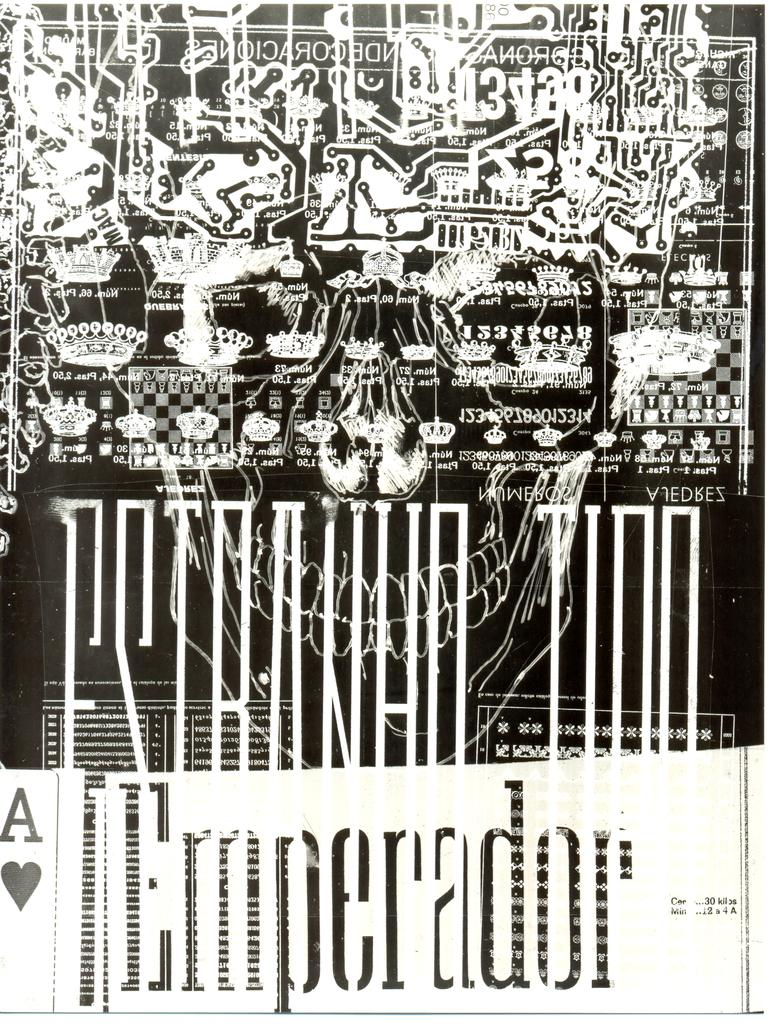<image>
Give a short and clear explanation of the subsequent image. Poster in black and white with the word "Emperador" on the bottom. 